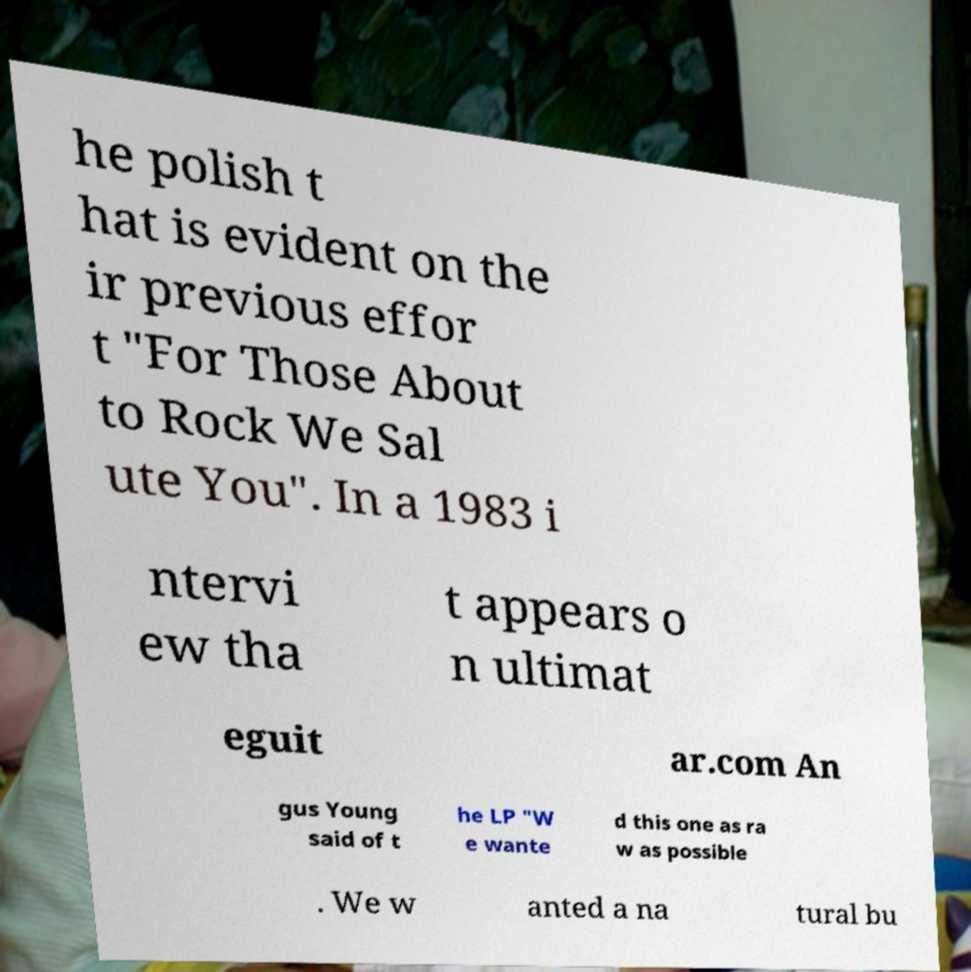Can you read and provide the text displayed in the image?This photo seems to have some interesting text. Can you extract and type it out for me? he polish t hat is evident on the ir previous effor t "For Those About to Rock We Sal ute You". In a 1983 i ntervi ew tha t appears o n ultimat eguit ar.com An gus Young said of t he LP "W e wante d this one as ra w as possible . We w anted a na tural bu 